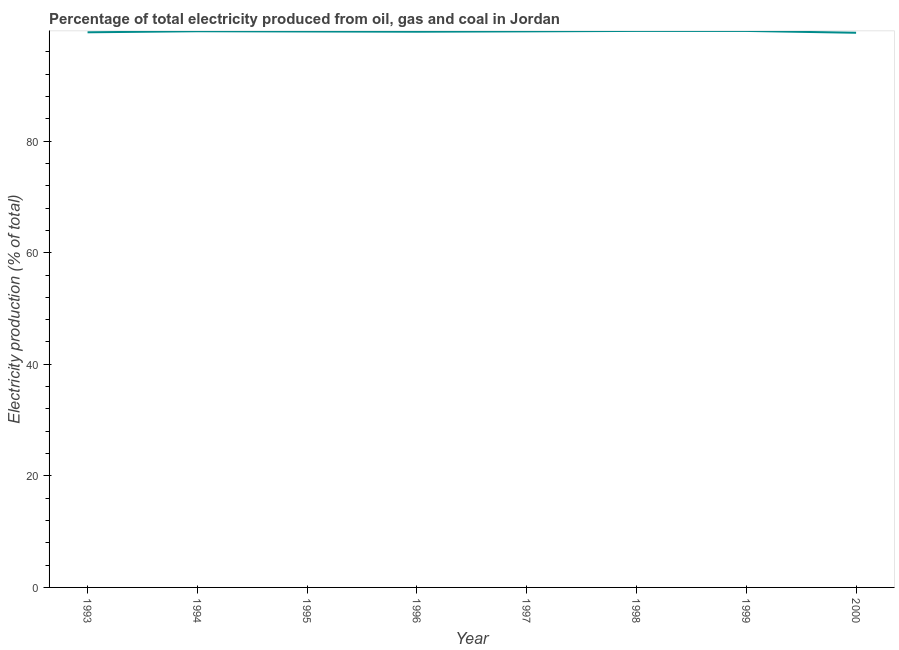What is the electricity production in 1999?
Give a very brief answer. 99.76. Across all years, what is the maximum electricity production?
Provide a short and direct response. 99.76. Across all years, what is the minimum electricity production?
Your answer should be compact. 99.43. What is the sum of the electricity production?
Offer a very short reply. 797.14. What is the difference between the electricity production in 1995 and 1996?
Keep it short and to the point. 0.04. What is the average electricity production per year?
Your answer should be very brief. 99.64. What is the median electricity production?
Offer a very short reply. 99.67. In how many years, is the electricity production greater than 20 %?
Make the answer very short. 8. What is the ratio of the electricity production in 1993 to that in 1997?
Provide a short and direct response. 1. Is the difference between the electricity production in 1994 and 1999 greater than the difference between any two years?
Ensure brevity in your answer.  No. What is the difference between the highest and the second highest electricity production?
Your response must be concise. 0. What is the difference between the highest and the lowest electricity production?
Your response must be concise. 0.33. Does the electricity production monotonically increase over the years?
Offer a very short reply. No. What is the difference between two consecutive major ticks on the Y-axis?
Provide a short and direct response. 20. Are the values on the major ticks of Y-axis written in scientific E-notation?
Provide a succinct answer. No. What is the title of the graph?
Make the answer very short. Percentage of total electricity produced from oil, gas and coal in Jordan. What is the label or title of the X-axis?
Provide a succinct answer. Year. What is the label or title of the Y-axis?
Provide a succinct answer. Electricity production (% of total). What is the Electricity production (% of total) of 1993?
Make the answer very short. 99.52. What is the Electricity production (% of total) in 1994?
Offer a very short reply. 99.7. What is the Electricity production (% of total) in 1995?
Provide a short and direct response. 99.66. What is the Electricity production (% of total) of 1996?
Ensure brevity in your answer.  99.62. What is the Electricity production (% of total) of 1997?
Provide a succinct answer. 99.68. What is the Electricity production (% of total) of 1998?
Your answer should be compact. 99.76. What is the Electricity production (% of total) of 1999?
Offer a very short reply. 99.76. What is the Electricity production (% of total) of 2000?
Provide a short and direct response. 99.43. What is the difference between the Electricity production (% of total) in 1993 and 1994?
Your answer should be compact. -0.19. What is the difference between the Electricity production (% of total) in 1993 and 1995?
Offer a terse response. -0.14. What is the difference between the Electricity production (% of total) in 1993 and 1996?
Make the answer very short. -0.1. What is the difference between the Electricity production (% of total) in 1993 and 1997?
Your answer should be very brief. -0.16. What is the difference between the Electricity production (% of total) in 1993 and 1998?
Provide a short and direct response. -0.25. What is the difference between the Electricity production (% of total) in 1993 and 1999?
Keep it short and to the point. -0.24. What is the difference between the Electricity production (% of total) in 1993 and 2000?
Keep it short and to the point. 0.09. What is the difference between the Electricity production (% of total) in 1994 and 1995?
Your response must be concise. 0.04. What is the difference between the Electricity production (% of total) in 1994 and 1996?
Offer a terse response. 0.08. What is the difference between the Electricity production (% of total) in 1994 and 1997?
Your answer should be compact. 0.02. What is the difference between the Electricity production (% of total) in 1994 and 1998?
Give a very brief answer. -0.06. What is the difference between the Electricity production (% of total) in 1994 and 1999?
Your response must be concise. -0.06. What is the difference between the Electricity production (% of total) in 1994 and 2000?
Provide a succinct answer. 0.27. What is the difference between the Electricity production (% of total) in 1995 and 1996?
Offer a terse response. 0.04. What is the difference between the Electricity production (% of total) in 1995 and 1997?
Your answer should be compact. -0.02. What is the difference between the Electricity production (% of total) in 1995 and 1998?
Provide a succinct answer. -0.1. What is the difference between the Electricity production (% of total) in 1995 and 1999?
Offer a very short reply. -0.1. What is the difference between the Electricity production (% of total) in 1995 and 2000?
Your answer should be compact. 0.23. What is the difference between the Electricity production (% of total) in 1996 and 1997?
Your response must be concise. -0.06. What is the difference between the Electricity production (% of total) in 1996 and 1998?
Provide a succinct answer. -0.14. What is the difference between the Electricity production (% of total) in 1996 and 1999?
Make the answer very short. -0.14. What is the difference between the Electricity production (% of total) in 1996 and 2000?
Offer a very short reply. 0.19. What is the difference between the Electricity production (% of total) in 1997 and 1998?
Your answer should be very brief. -0.08. What is the difference between the Electricity production (% of total) in 1997 and 1999?
Your answer should be very brief. -0.08. What is the difference between the Electricity production (% of total) in 1997 and 2000?
Your answer should be very brief. 0.25. What is the difference between the Electricity production (% of total) in 1998 and 1999?
Ensure brevity in your answer.  0. What is the difference between the Electricity production (% of total) in 1998 and 2000?
Your response must be concise. 0.33. What is the difference between the Electricity production (% of total) in 1999 and 2000?
Your answer should be compact. 0.33. What is the ratio of the Electricity production (% of total) in 1993 to that in 1995?
Your answer should be compact. 1. What is the ratio of the Electricity production (% of total) in 1993 to that in 1996?
Your response must be concise. 1. What is the ratio of the Electricity production (% of total) in 1993 to that in 1997?
Give a very brief answer. 1. What is the ratio of the Electricity production (% of total) in 1993 to that in 1998?
Your answer should be very brief. 1. What is the ratio of the Electricity production (% of total) in 1993 to that in 1999?
Your answer should be very brief. 1. What is the ratio of the Electricity production (% of total) in 1994 to that in 1995?
Provide a succinct answer. 1. What is the ratio of the Electricity production (% of total) in 1994 to that in 1996?
Your answer should be very brief. 1. What is the ratio of the Electricity production (% of total) in 1994 to that in 1997?
Ensure brevity in your answer.  1. What is the ratio of the Electricity production (% of total) in 1994 to that in 1998?
Make the answer very short. 1. What is the ratio of the Electricity production (% of total) in 1994 to that in 1999?
Give a very brief answer. 1. What is the ratio of the Electricity production (% of total) in 1994 to that in 2000?
Your response must be concise. 1. What is the ratio of the Electricity production (% of total) in 1995 to that in 1996?
Ensure brevity in your answer.  1. What is the ratio of the Electricity production (% of total) in 1995 to that in 1997?
Make the answer very short. 1. What is the ratio of the Electricity production (% of total) in 1995 to that in 1998?
Give a very brief answer. 1. What is the ratio of the Electricity production (% of total) in 1995 to that in 1999?
Offer a very short reply. 1. What is the ratio of the Electricity production (% of total) in 1996 to that in 1997?
Provide a short and direct response. 1. What is the ratio of the Electricity production (% of total) in 1996 to that in 2000?
Keep it short and to the point. 1. What is the ratio of the Electricity production (% of total) in 1997 to that in 1999?
Your answer should be very brief. 1. What is the ratio of the Electricity production (% of total) in 1999 to that in 2000?
Provide a succinct answer. 1. 